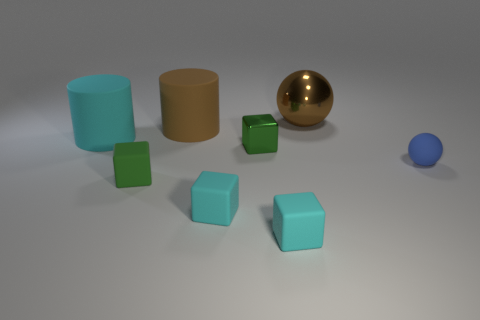How would you describe the lighting and shadows in the image? The lighting in the image is soft and diffused, coming from above as indicated by the soft shadows beneath each object. These shadows suggest an interior setting with a single light source, such as a ceiling light. The objects' reflections and shadows provide a sense of depth and texture to the scene. 